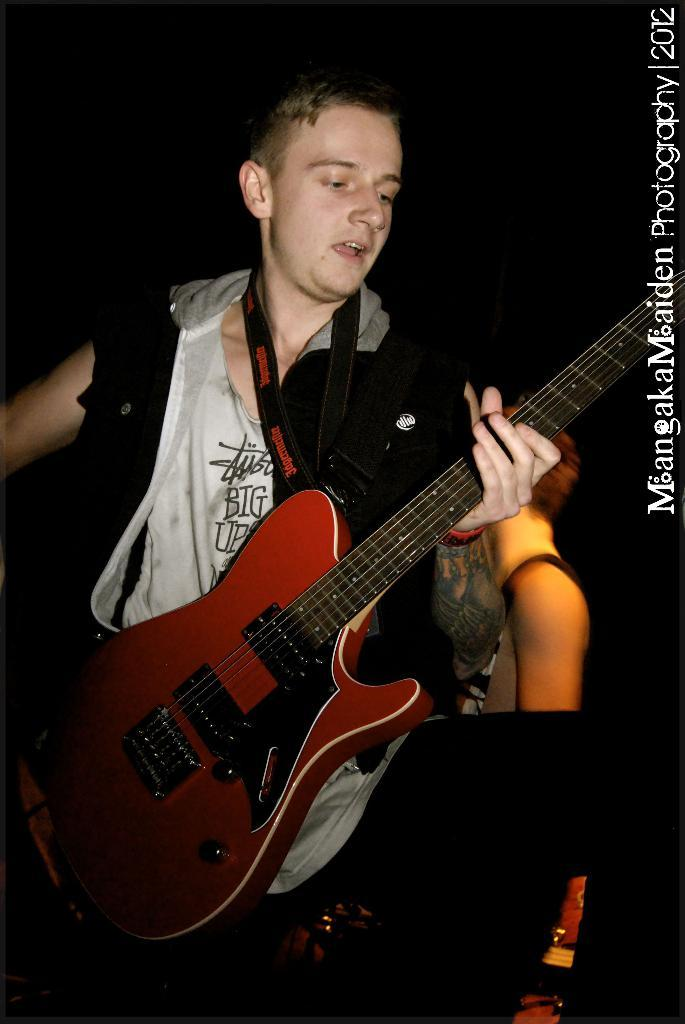What is the main subject of the image? The main subject of the image is a boy. What is the boy doing in the image? The boy is standing and singing. What is the boy holding in the image? The boy is holding a brown-colored music instrument. Can you describe the background of the image? There are people in the background of the image. How many geese are flying in the image? There are no geese present in the image. What type of shock can be seen affecting the boy in the image? There is no shock or any indication of an electrical shock in the image. 